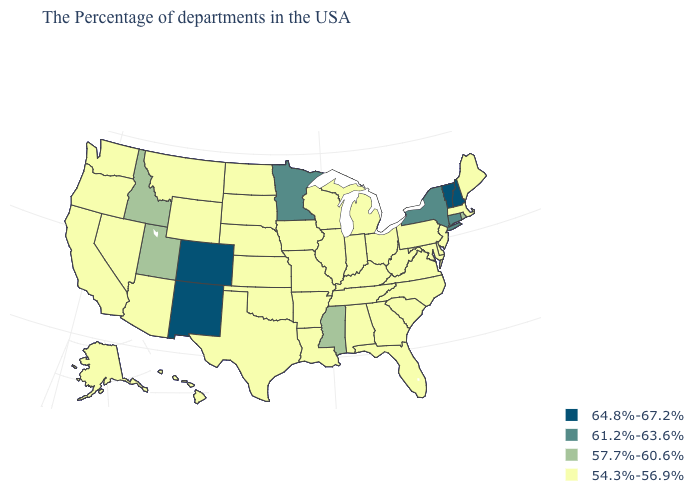What is the value of Vermont?
Concise answer only. 64.8%-67.2%. Does the first symbol in the legend represent the smallest category?
Short answer required. No. Name the states that have a value in the range 54.3%-56.9%?
Keep it brief. Maine, Massachusetts, New Jersey, Delaware, Maryland, Pennsylvania, Virginia, North Carolina, South Carolina, West Virginia, Ohio, Florida, Georgia, Michigan, Kentucky, Indiana, Alabama, Tennessee, Wisconsin, Illinois, Louisiana, Missouri, Arkansas, Iowa, Kansas, Nebraska, Oklahoma, Texas, South Dakota, North Dakota, Wyoming, Montana, Arizona, Nevada, California, Washington, Oregon, Alaska, Hawaii. What is the highest value in states that border New Jersey?
Short answer required. 61.2%-63.6%. Name the states that have a value in the range 61.2%-63.6%?
Be succinct. Connecticut, New York, Minnesota. Does Massachusetts have the lowest value in the Northeast?
Answer briefly. Yes. How many symbols are there in the legend?
Be succinct. 4. Does New Hampshire have the lowest value in the USA?
Concise answer only. No. Which states have the highest value in the USA?
Give a very brief answer. New Hampshire, Vermont, Colorado, New Mexico. Which states have the lowest value in the USA?
Answer briefly. Maine, Massachusetts, New Jersey, Delaware, Maryland, Pennsylvania, Virginia, North Carolina, South Carolina, West Virginia, Ohio, Florida, Georgia, Michigan, Kentucky, Indiana, Alabama, Tennessee, Wisconsin, Illinois, Louisiana, Missouri, Arkansas, Iowa, Kansas, Nebraska, Oklahoma, Texas, South Dakota, North Dakota, Wyoming, Montana, Arizona, Nevada, California, Washington, Oregon, Alaska, Hawaii. Name the states that have a value in the range 54.3%-56.9%?
Give a very brief answer. Maine, Massachusetts, New Jersey, Delaware, Maryland, Pennsylvania, Virginia, North Carolina, South Carolina, West Virginia, Ohio, Florida, Georgia, Michigan, Kentucky, Indiana, Alabama, Tennessee, Wisconsin, Illinois, Louisiana, Missouri, Arkansas, Iowa, Kansas, Nebraska, Oklahoma, Texas, South Dakota, North Dakota, Wyoming, Montana, Arizona, Nevada, California, Washington, Oregon, Alaska, Hawaii. Among the states that border Wyoming , does South Dakota have the highest value?
Quick response, please. No. Name the states that have a value in the range 61.2%-63.6%?
Be succinct. Connecticut, New York, Minnesota. What is the lowest value in states that border Delaware?
Answer briefly. 54.3%-56.9%. Name the states that have a value in the range 61.2%-63.6%?
Write a very short answer. Connecticut, New York, Minnesota. 